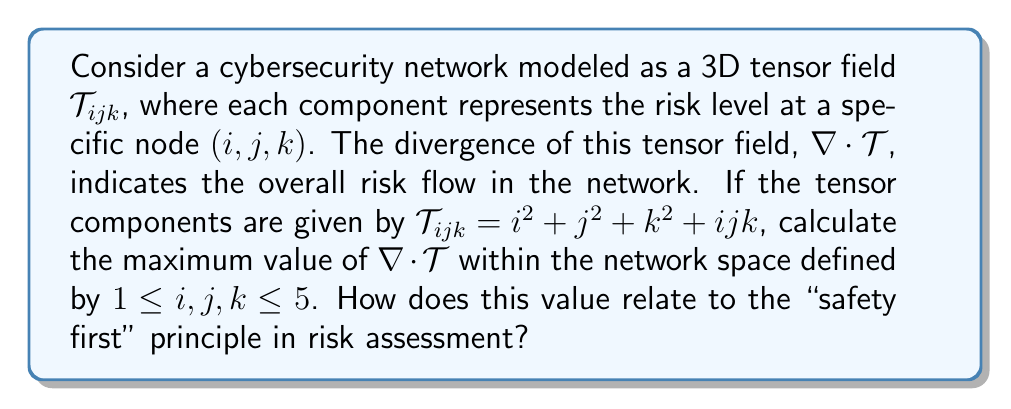Can you solve this math problem? 1. The divergence of a 3D tensor field is given by:

   $$\nabla \cdot T = \frac{\partial T_{111}}{\partial i} + \frac{\partial T_{222}}{\partial j} + \frac{\partial T_{333}}{\partial k}$$

2. Calculate the partial derivatives:
   $$\frac{\partial T_{111}}{\partial i} = 2i + jk$$
   $$\frac{\partial T_{222}}{\partial j} = 2j + ik$$
   $$\frac{\partial T_{333}}{\partial k} = 2k + ij$$

3. Sum the partial derivatives:
   $$\nabla \cdot T = (2i + jk) + (2j + ik) + (2k + ij)$$
   $$\nabla \cdot T = 2i + 2j + 2k + 2ijk$$

4. To find the maximum value, we need to evaluate this expression at the extremes of our domain:
   $$1 \leq i,j,k \leq 5$$

5. The maximum will occur when $i = j = k = 5$:
   $$\nabla \cdot T_{max} = 2(5) + 2(5) + 2(5) + 2(5)(5)(5)$$
   $$\nabla \cdot T_{max} = 30 + 250 = 280$$

6. This maximum value of 280 represents the highest potential risk flow in the network. In relation to the "safety first" principle, this value indicates the worst-case scenario that needs to be addressed with the highest priority in risk assessment and mitigation strategies.
Answer: 280 